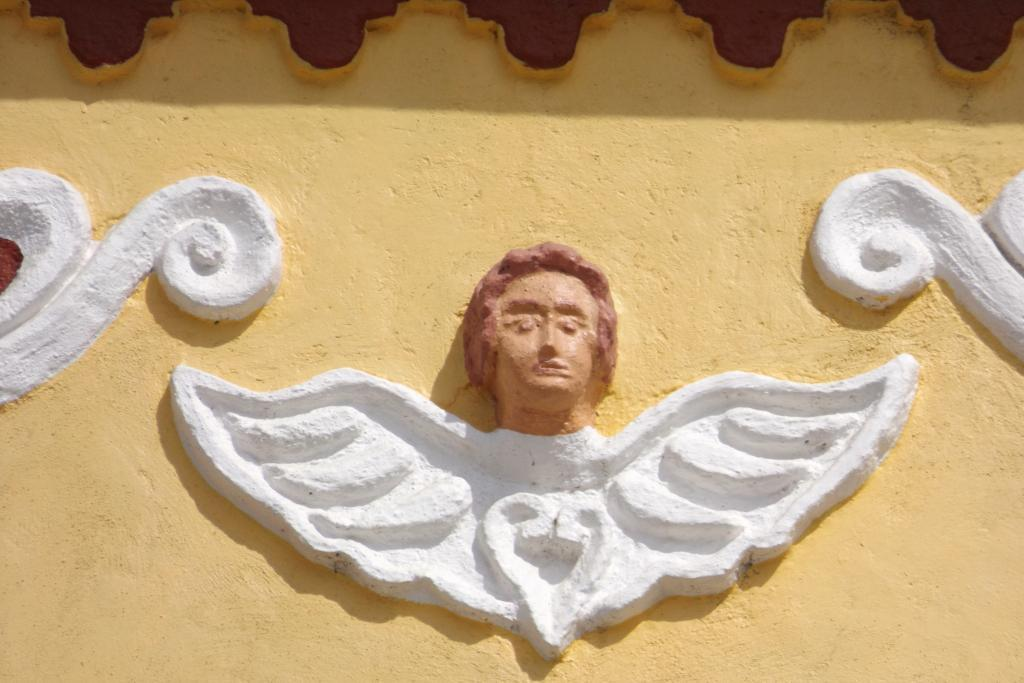What can be seen on the wall in the image? There is carving on the wall in the image. What type of squirrel can be seen climbing the brick wall in the image? There is no squirrel present in the image, and the wall is not made of bricks. 